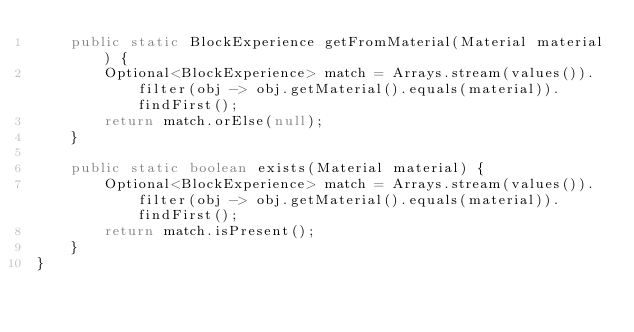<code> <loc_0><loc_0><loc_500><loc_500><_Java_>    public static BlockExperience getFromMaterial(Material material) {
        Optional<BlockExperience> match = Arrays.stream(values()).filter(obj -> obj.getMaterial().equals(material)).findFirst();
        return match.orElse(null);
    }

    public static boolean exists(Material material) {
        Optional<BlockExperience> match = Arrays.stream(values()).filter(obj -> obj.getMaterial().equals(material)).findFirst();
        return match.isPresent();
    }
}
</code> 